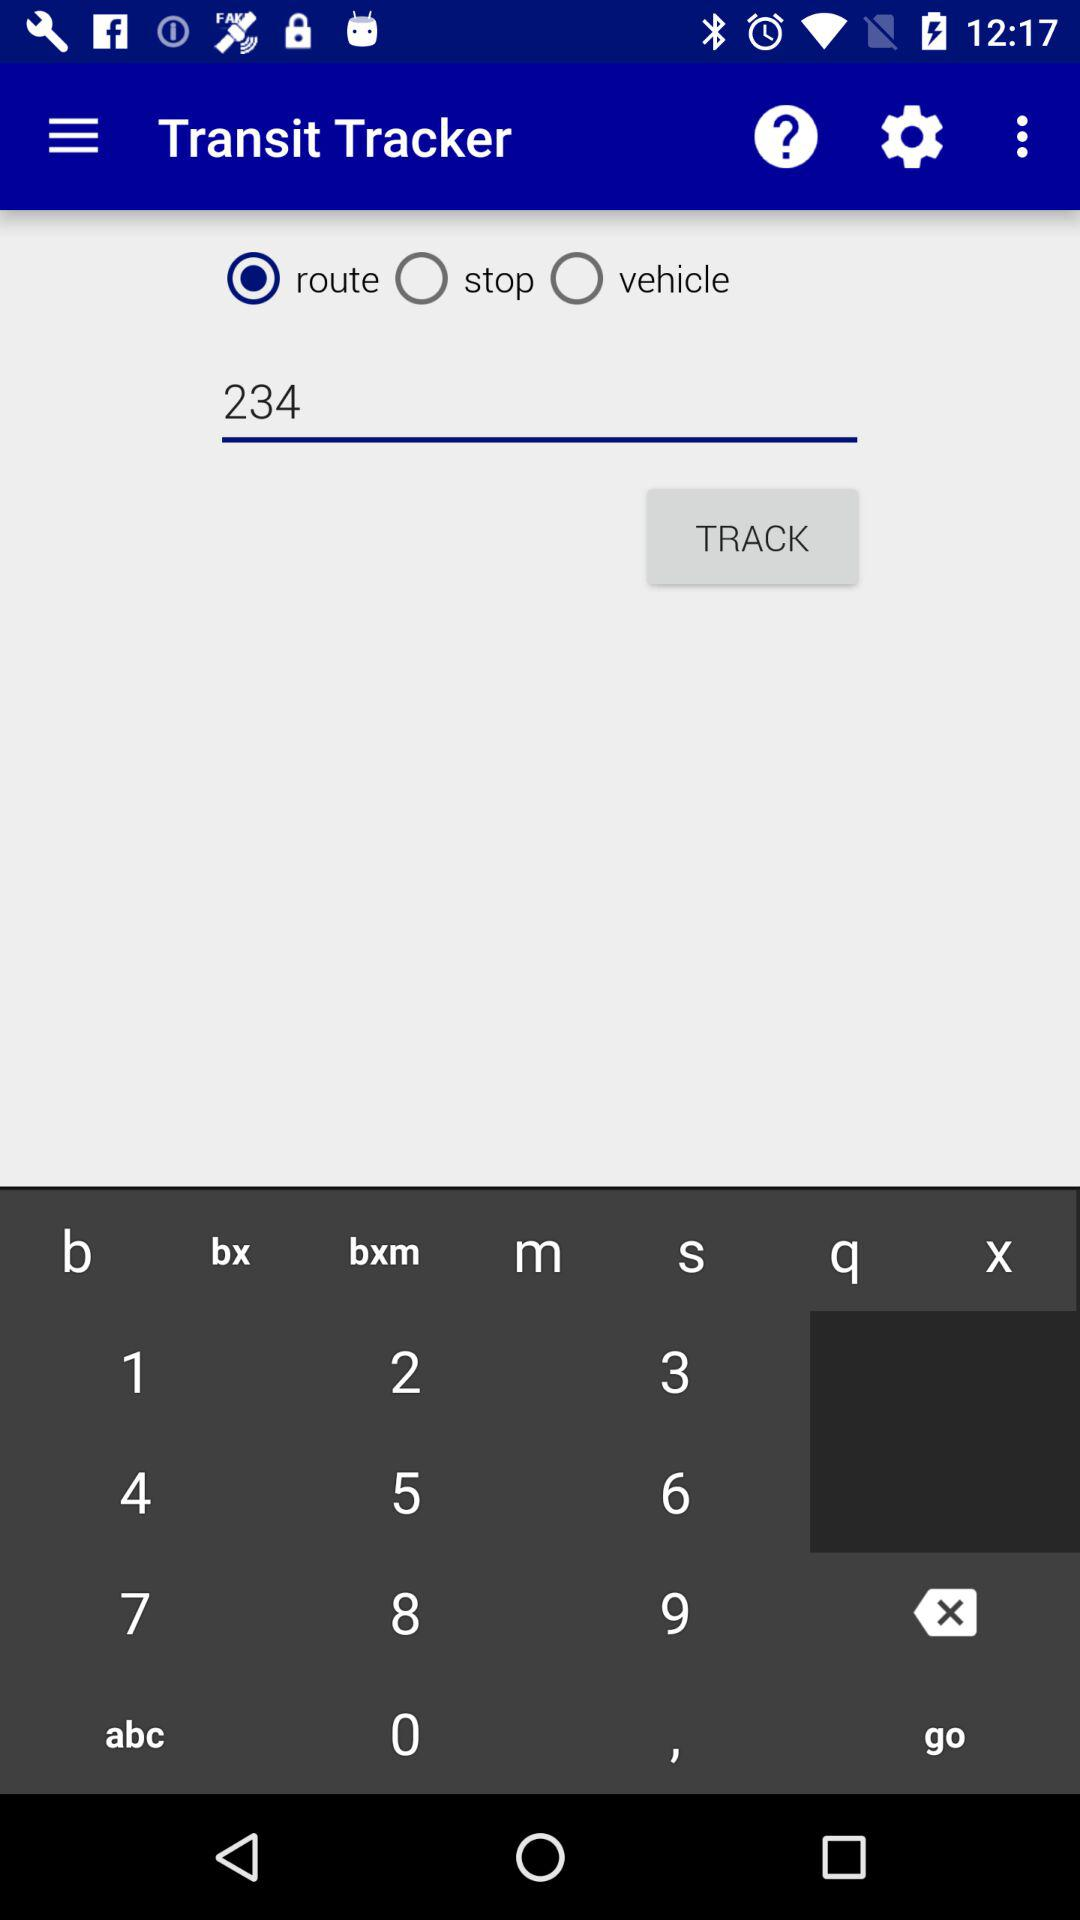Which option is selected? The selected option is "route". 